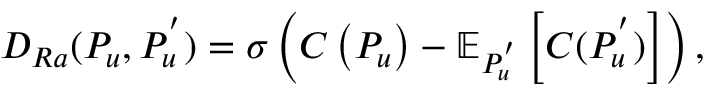Convert formula to latex. <formula><loc_0><loc_0><loc_500><loc_500>D _ { R a } ( P _ { u } , P _ { u } ^ { ^ { \prime } } ) = \sigma \left ( C \left ( P _ { u } \right ) - \mathbb { E } _ { P _ { u } ^ { ^ { \prime } } } \left [ C ( P _ { u } ^ { ^ { \prime } } ) \right ] \right ) ,</formula> 